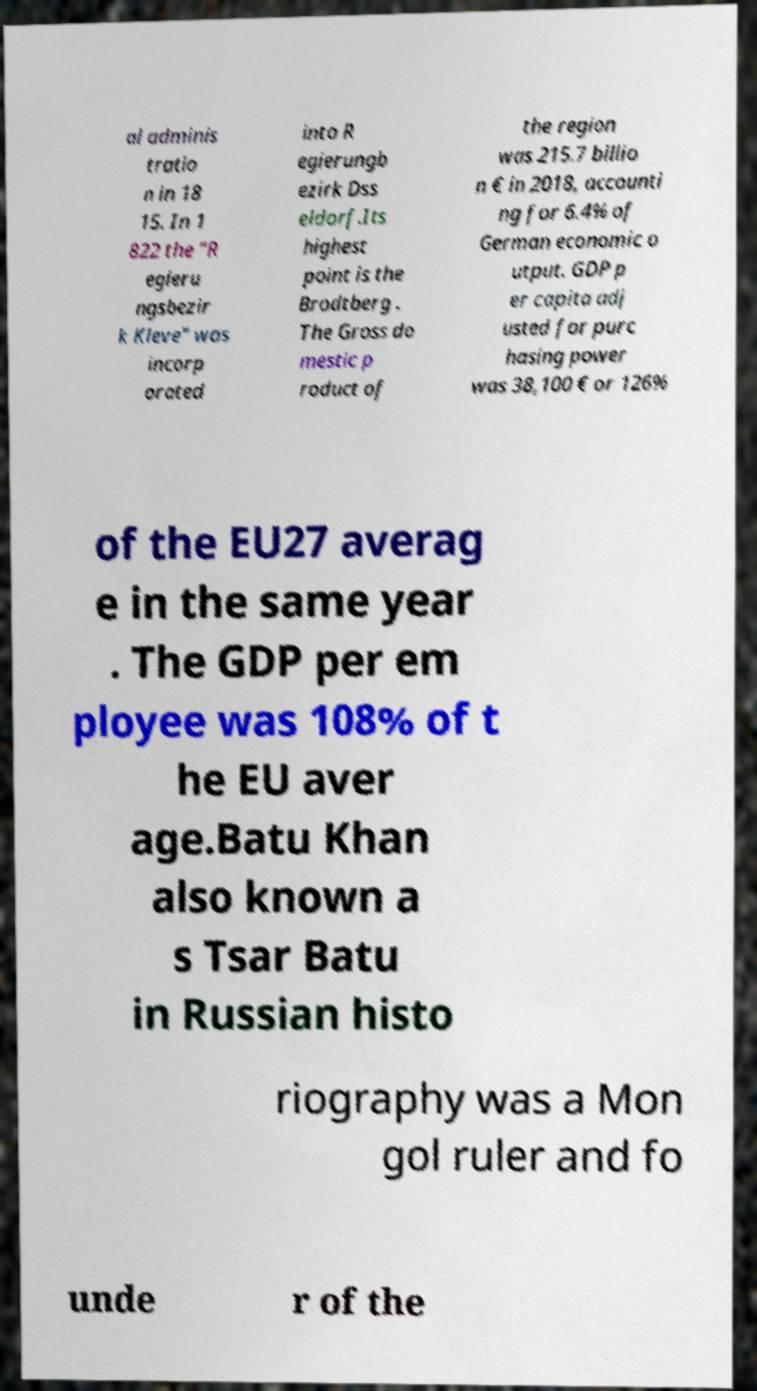I need the written content from this picture converted into text. Can you do that? al adminis tratio n in 18 15. In 1 822 the "R egieru ngsbezir k Kleve" was incorp orated into R egierungb ezirk Dss eldorf.Its highest point is the Brodtberg . The Gross do mestic p roduct of the region was 215.7 billio n € in 2018, accounti ng for 6.4% of German economic o utput. GDP p er capita adj usted for purc hasing power was 38,100 € or 126% of the EU27 averag e in the same year . The GDP per em ployee was 108% of t he EU aver age.Batu Khan also known a s Tsar Batu in Russian histo riography was a Mon gol ruler and fo unde r of the 